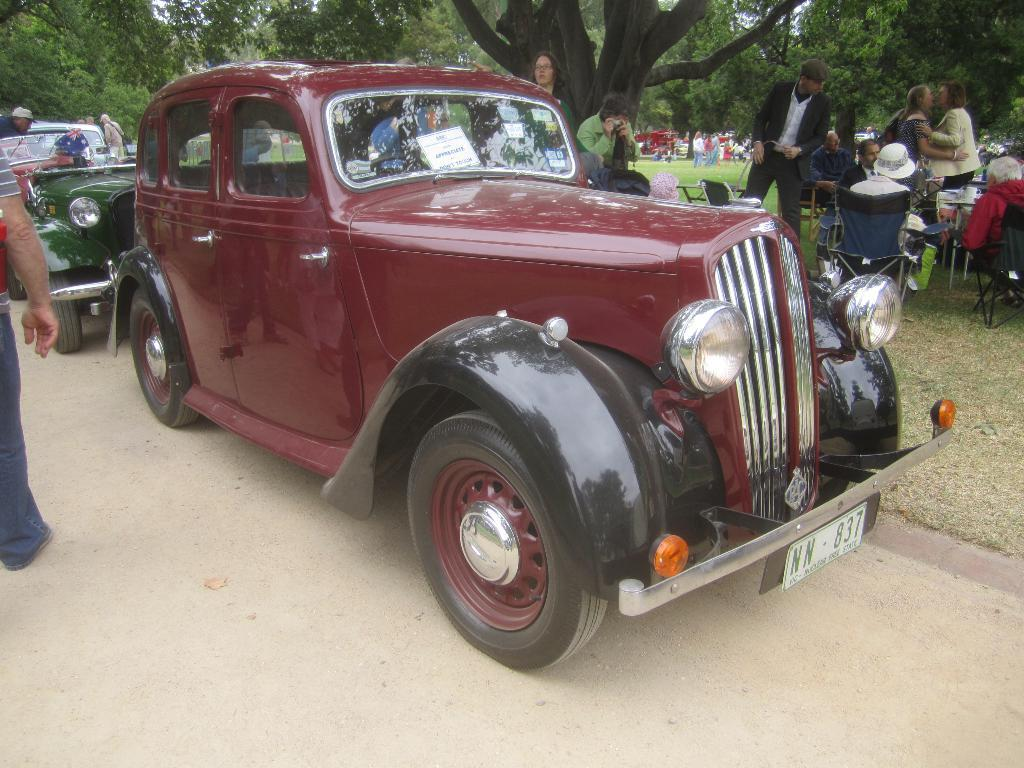What is the main subject in the center of the image? There is a car in the center of the image. Where is the car located? The car is on a road. What can be seen in the background of the image? There are people sitting on chairs and trees visible in the background of the image. What type of cabbage is being used to cut with scissors in the image? There is no cabbage or scissors present in the image; it features a car on a road with people sitting on chairs and trees in the background. 